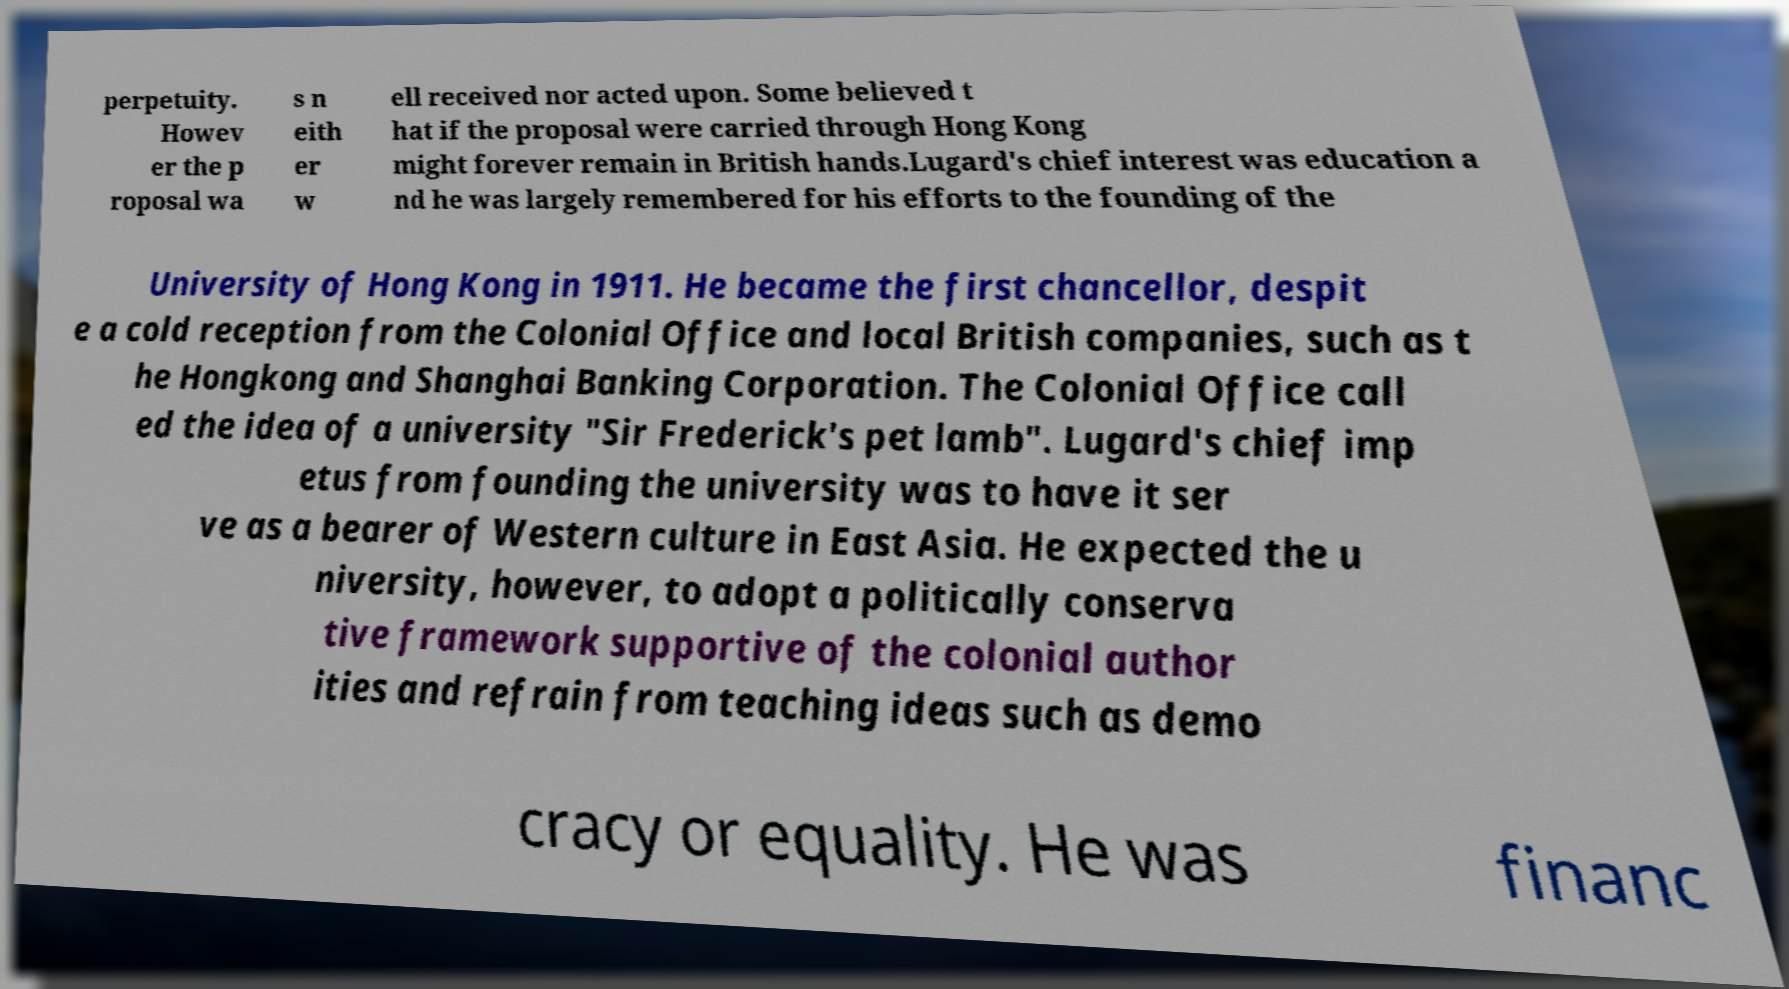There's text embedded in this image that I need extracted. Can you transcribe it verbatim? perpetuity. Howev er the p roposal wa s n eith er w ell received nor acted upon. Some believed t hat if the proposal were carried through Hong Kong might forever remain in British hands.Lugard's chief interest was education a nd he was largely remembered for his efforts to the founding of the University of Hong Kong in 1911. He became the first chancellor, despit e a cold reception from the Colonial Office and local British companies, such as t he Hongkong and Shanghai Banking Corporation. The Colonial Office call ed the idea of a university "Sir Frederick's pet lamb". Lugard's chief imp etus from founding the university was to have it ser ve as a bearer of Western culture in East Asia. He expected the u niversity, however, to adopt a politically conserva tive framework supportive of the colonial author ities and refrain from teaching ideas such as demo cracy or equality. He was financ 